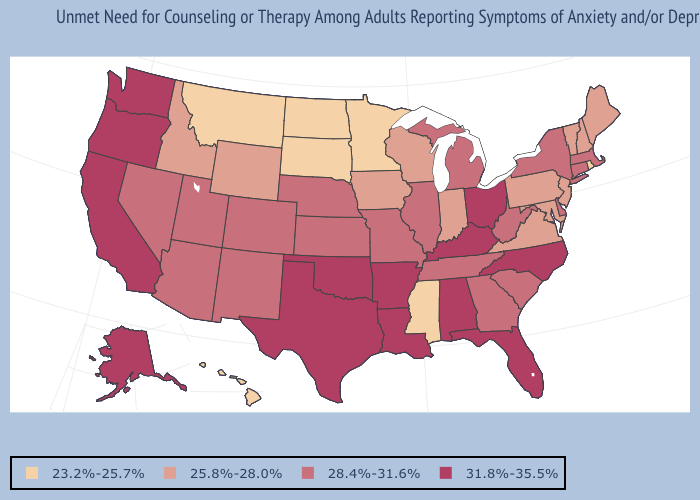How many symbols are there in the legend?
Quick response, please. 4. Name the states that have a value in the range 25.8%-28.0%?
Keep it brief. Idaho, Indiana, Iowa, Maine, Maryland, New Hampshire, New Jersey, Pennsylvania, Vermont, Virginia, Wisconsin, Wyoming. Is the legend a continuous bar?
Be succinct. No. Name the states that have a value in the range 23.2%-25.7%?
Quick response, please. Hawaii, Minnesota, Mississippi, Montana, North Dakota, Rhode Island, South Dakota. Name the states that have a value in the range 23.2%-25.7%?
Short answer required. Hawaii, Minnesota, Mississippi, Montana, North Dakota, Rhode Island, South Dakota. Name the states that have a value in the range 28.4%-31.6%?
Keep it brief. Arizona, Colorado, Connecticut, Delaware, Georgia, Illinois, Kansas, Massachusetts, Michigan, Missouri, Nebraska, Nevada, New Mexico, New York, South Carolina, Tennessee, Utah, West Virginia. Does Alabama have the highest value in the USA?
Answer briefly. Yes. What is the value of Missouri?
Be succinct. 28.4%-31.6%. Name the states that have a value in the range 31.8%-35.5%?
Give a very brief answer. Alabama, Alaska, Arkansas, California, Florida, Kentucky, Louisiana, North Carolina, Ohio, Oklahoma, Oregon, Texas, Washington. How many symbols are there in the legend?
Answer briefly. 4. What is the value of Maine?
Write a very short answer. 25.8%-28.0%. Among the states that border Utah , does Idaho have the highest value?
Short answer required. No. Does the map have missing data?
Write a very short answer. No. Among the states that border Nevada , does Utah have the lowest value?
Keep it brief. No. 